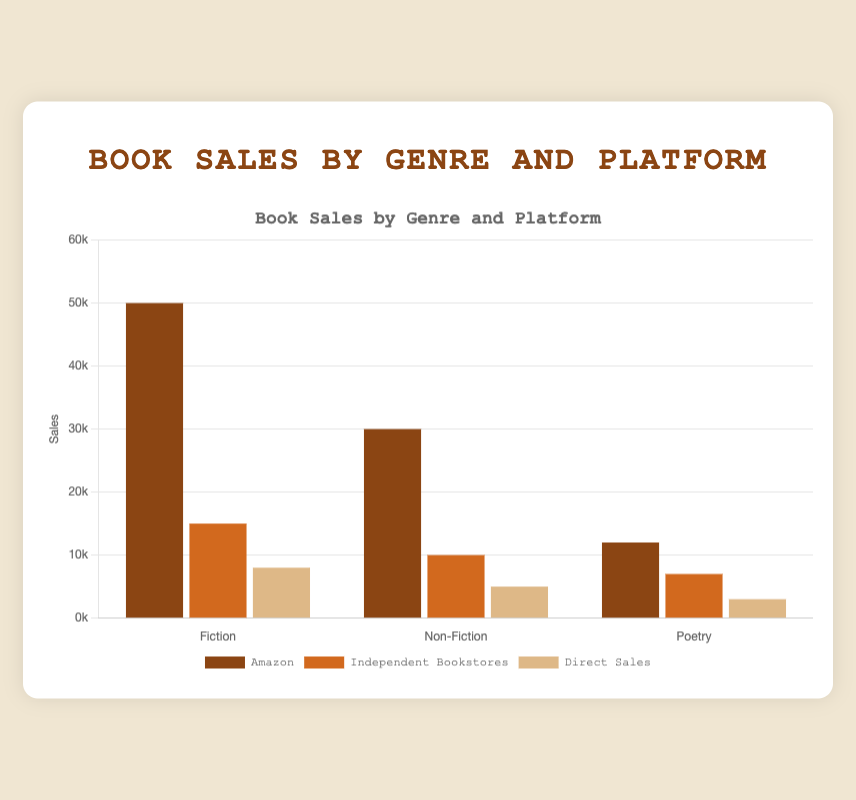Which genre has the highest overall sales across all platforms? Look at the bar corresponding to each genre, sum the values from all platforms for each genre. Fiction: 50000 + 15000 + 8000 = 73000, Non-Fiction: 30000 + 10000 + 5000 = 45000, Poetry: 12000 + 7000 + 3000 = 22000. Fiction has the highest total sales.
Answer: Fiction Which platform has the highest sales for Non-Fiction books? Look at the heights of the bars representing Non-Fiction sales across all platforms (Amazon, Independent Bookstores, Direct Sales). The tallest bar represents Amazon with 30000 sales.
Answer: Amazon What is the difference in sales between Fiction and Poetry on Amazon? Look at the bars representing Amazon sales for Fiction and Poetry. Fiction: 50000, Poetry: 12000. The difference is 50000 - 12000 = 38000.
Answer: 38000 Which genre has the lowest sales in Independent Bookstores? Look at the bars corresponding to Independent Bookstores for each genre. Fiction: 15000, Non-Fiction: 10000, Poetry: 7000. The shortest bar represents Poetry.
Answer: Poetry Is there a genre where Direct Sales outperform Independent Bookstores? Compare the bars for Direct Sales and Independent Bookstores for each genre. For Fiction, Independent Bookstores (15000) > Direct Sales (8000); for Non-Fiction, Independent Bookstores (10000) > Direct Sales (5000); for Poetry, Independent Bookstores (7000) > Direct Sales (3000). No genre meets the criteria.
Answer: No What is the combined sales of Non-Fiction and Poetry on Direct Sales? Look at the bars representing Direct Sales for Non-Fiction and Poetry. Non-Fiction: 5000, Poetry: 3000. Add these values, 5000 + 3000 = 8000.
Answer: 8000 Between Fiction and Non-Fiction, which genre has higher combined sales in Independent Bookstores and Direct Sales? Calculate the combined sales for Fiction and Non-Fiction in the specified platforms. Fiction: 15000 (Independent) + 8000 (Direct) = 23000; Non-Fiction: 10000 (Independent) + 5000 (Direct) = 15000. Fiction has higher combined sales.
Answer: Fiction Which genre's Amazon sales exceed the combined sales on all other platforms? Look at the Amazon sales for each genre and compare it to the combined sales of the other platforms. Fiction: Amazon 50000; Other platforms: 15000 (Independent) + 8000 (Direct) = 23000. Non-Fiction: Amazon 30000; Other platforms: 10000 (Independent) + 5000 (Direct) = 15000. Poetry: Amazon 12000; Other platforms: 7000 (Independent) + 3000 (Direct) = 10000. All Amazon sales exceed combined sales on other platforms for their respective genres.
Answer: All genres What proportion of total Fiction sales are made through Amazon? First, find total Fiction sales: 50000 (Amazon) + 15000 (Independent) + 8000 (Direct) = 73000. Then, divide the Amazon sales by the total Fiction sales: 50000 / 73000. The proportion is approximately 68.5%. (50000/73000 = ~0.685).
Answer: ~68.5% Rank the genres by total sales from highest to lowest. Calculate the total sales for each genre. Fiction: 73000 (total), Non-Fiction: 45000 (total), Poetry: 22000 (total). Rank them: Fiction > Non-Fiction > Poetry.
Answer: Fiction > Non-Fiction > Poetry 